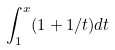Convert formula to latex. <formula><loc_0><loc_0><loc_500><loc_500>\int _ { 1 } ^ { x } ( 1 + 1 / t ) d t</formula> 